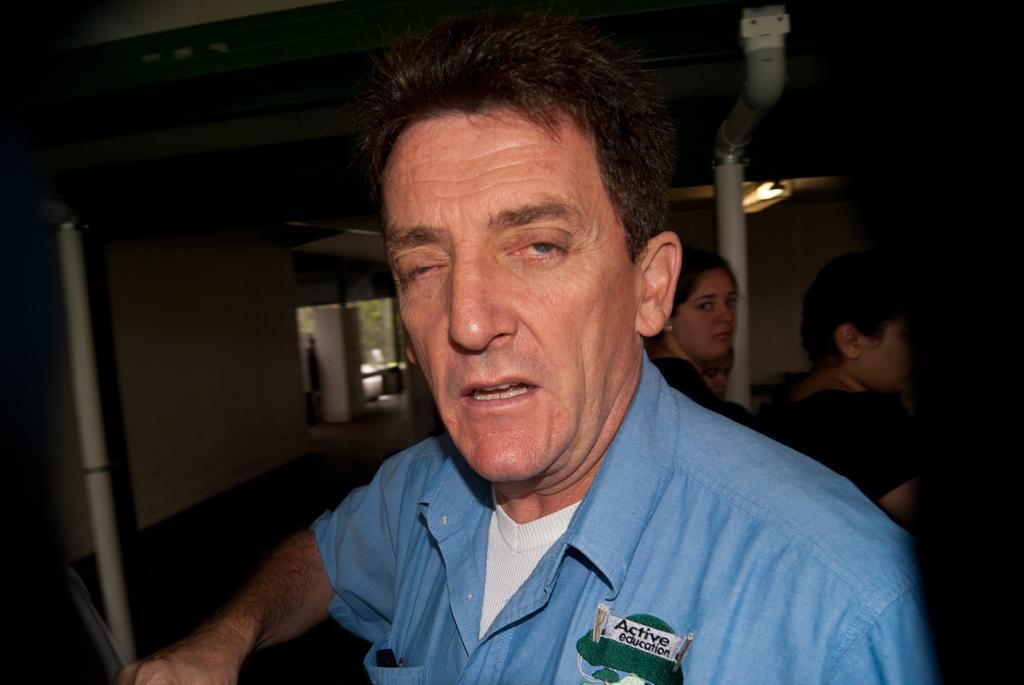Describe this image in one or two sentences. Here I can see a man wearing a blue color shirt and looking at the picture. It seems like he is speaking. At the back of him there are some more people. In the background, I can see a wall, pillar and a car. 